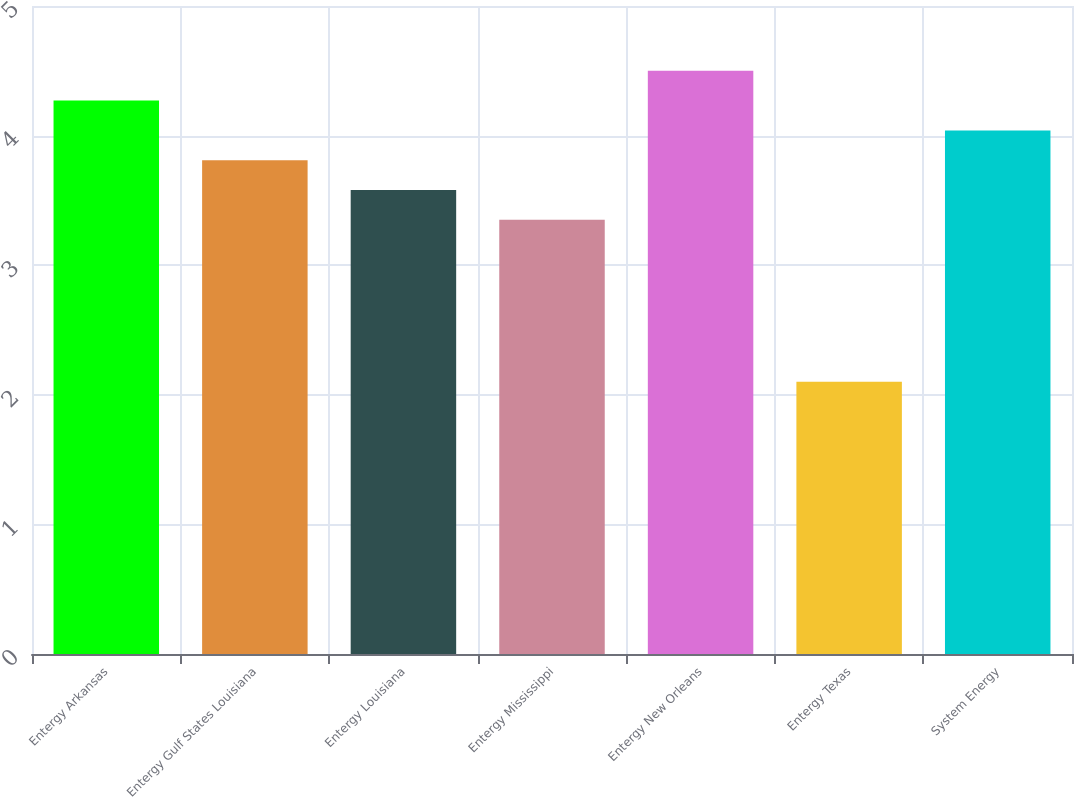Convert chart to OTSL. <chart><loc_0><loc_0><loc_500><loc_500><bar_chart><fcel>Entergy Arkansas<fcel>Entergy Gulf States Louisiana<fcel>Entergy Louisiana<fcel>Entergy Mississippi<fcel>Entergy New Orleans<fcel>Entergy Texas<fcel>System Energy<nl><fcel>4.27<fcel>3.81<fcel>3.58<fcel>3.35<fcel>4.5<fcel>2.1<fcel>4.04<nl></chart> 